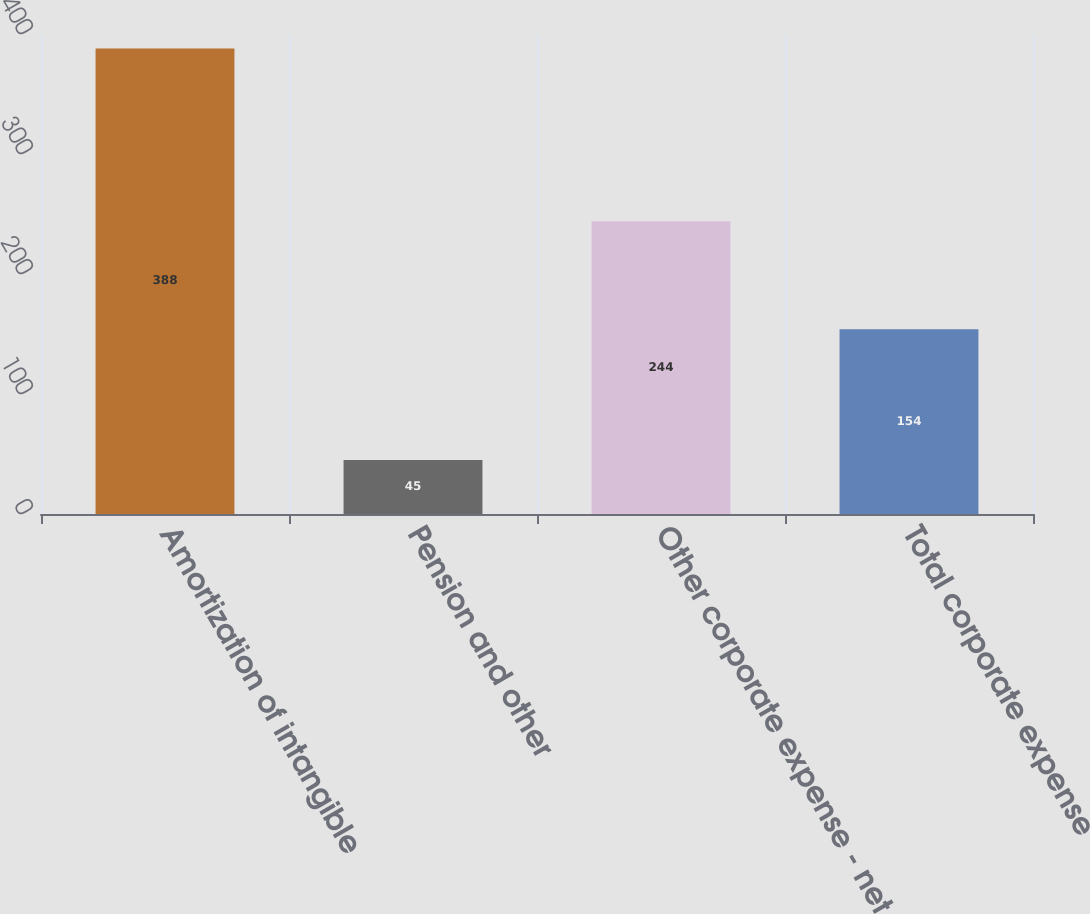Convert chart. <chart><loc_0><loc_0><loc_500><loc_500><bar_chart><fcel>Amortization of intangible<fcel>Pension and other<fcel>Other corporate expense - net<fcel>Total corporate expense<nl><fcel>388<fcel>45<fcel>244<fcel>154<nl></chart> 